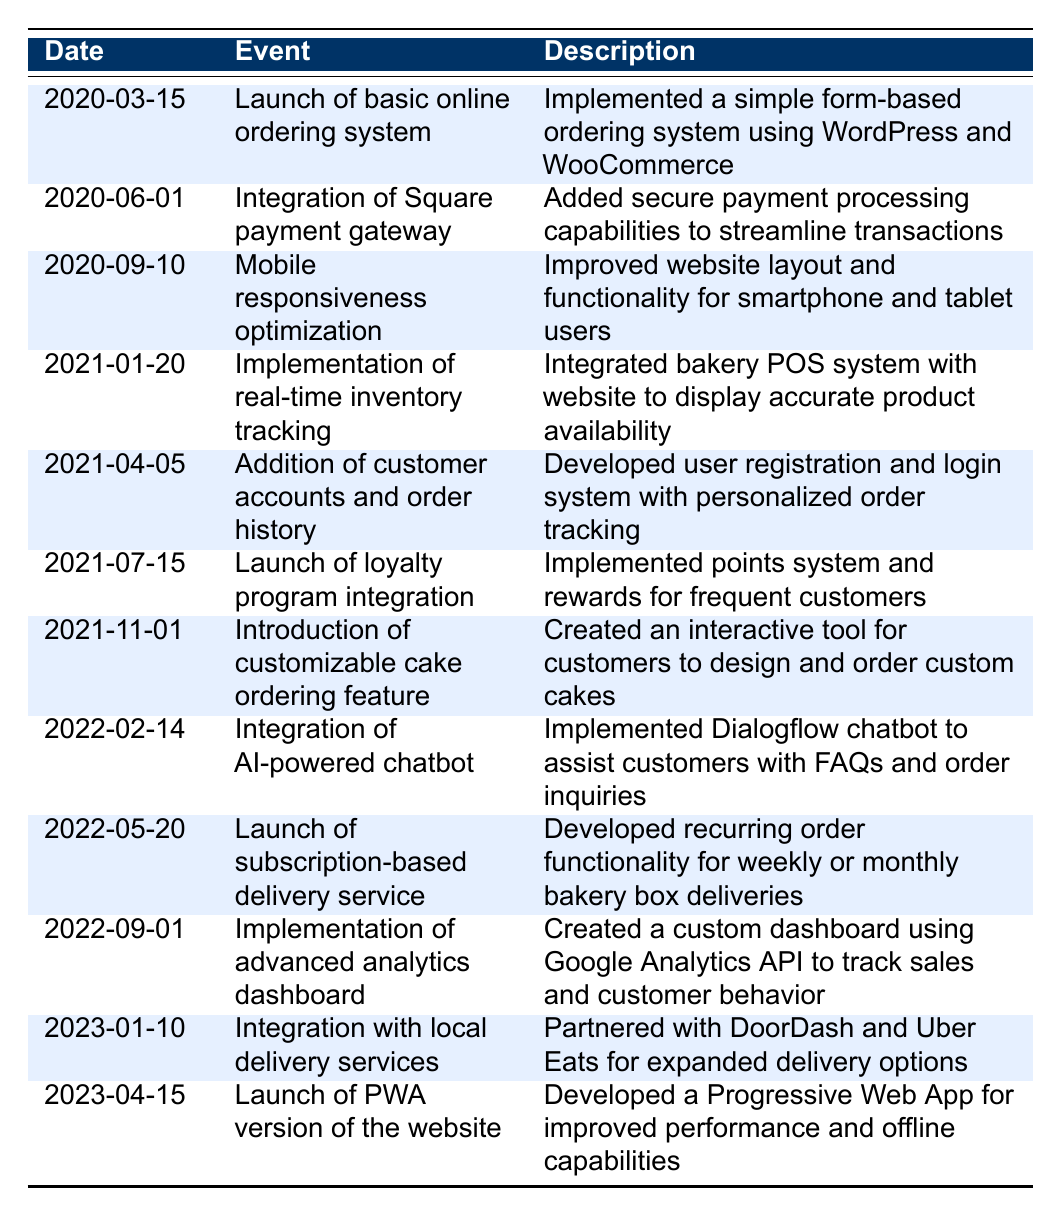What was the first major update to the online ordering system? The first major update is the "Launch of basic online ordering system" on "2020-03-15". This refers to the implementation of a form-based ordering system.
Answer: Launch of basic online ordering system How many updates were made to the online ordering system in 2021? There were four updates in 2021 which are: "Implementation of real-time inventory tracking" on "2021-01-20", "Addition of customer accounts and order history" on "2021-04-05", "Launch of loyalty program integration" on "2021-07-15", and "Introduction of customizable cake ordering feature" on "2021-11-01".
Answer: 4 Did the bakery introduce a subscription service for deliveries? Yes, the "Launch of subscription-based delivery service" occurred on "2022-05-20". This indicates that they developed a service for recurring orders.
Answer: Yes What event took place after the integration of the AI-powered chatbot? The event that took place after the AI-powered chatbot integration on "2022-02-14" is the "Launch of subscription-based delivery service" on "2022-05-20". This shows the sequence of updates in the timeline.
Answer: Launch of subscription-based delivery service What is the interval between the launch of the basic online ordering system and the mobile responsiveness optimization? The interval between "2020-03-15" and "2020-09-10" is 6 months. This can be calculated by noting that March to September accounts for 6 months.
Answer: 6 months Which two updates were made in 2022? The two updates made in 2022 are "Integration of AI-powered chatbot" on "2022-02-14" and "Launch of subscription-based delivery service" on "2022-05-20".
Answer: Integration of AI-powered chatbot, Launch of subscription-based delivery service How many features related to customer interaction were launched between 2021 and 2022? Three features were related to customer interaction: "Addition of customer accounts and order history" (2021), "Launch of loyalty program integration" (2021), and "Integration of AI-powered chatbot" (2022). Therefore, the total is three features.
Answer: 3 Was a partnership with a local delivery service established? Yes, the bakery partnered with local delivery services specifically mentioned as DoorDash and Uber Eats, noted in the event dated "2023-01-10".
Answer: Yes What was the last update to the online ordering system as per the table? The last update listed is "Launch of PWA version of the website" on "2023-04-15", which indicates that a Progressive Web App was developed.
Answer: Launch of PWA version of the website 